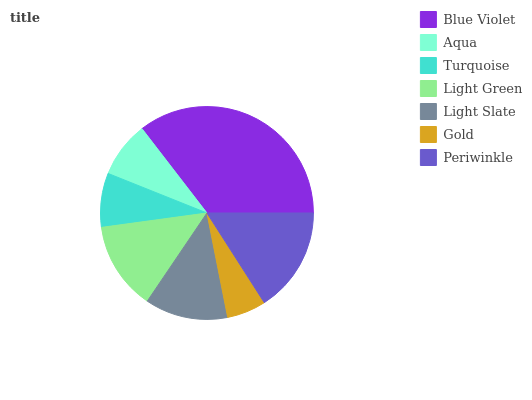Is Gold the minimum?
Answer yes or no. Yes. Is Blue Violet the maximum?
Answer yes or no. Yes. Is Aqua the minimum?
Answer yes or no. No. Is Aqua the maximum?
Answer yes or no. No. Is Blue Violet greater than Aqua?
Answer yes or no. Yes. Is Aqua less than Blue Violet?
Answer yes or no. Yes. Is Aqua greater than Blue Violet?
Answer yes or no. No. Is Blue Violet less than Aqua?
Answer yes or no. No. Is Light Slate the high median?
Answer yes or no. Yes. Is Light Slate the low median?
Answer yes or no. Yes. Is Aqua the high median?
Answer yes or no. No. Is Gold the low median?
Answer yes or no. No. 